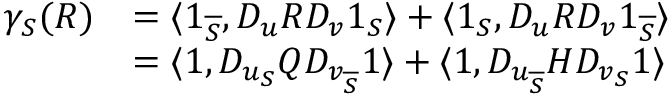Convert formula to latex. <formula><loc_0><loc_0><loc_500><loc_500>\begin{array} { r l } { \gamma _ { S } ( R ) } & { = \langle 1 _ { \overline { S } } , D _ { u } R D _ { v } 1 _ { S } \rangle + \langle 1 _ { S } , D _ { u } R D _ { v } 1 _ { \overline { S } } \rangle } \\ & { = \langle 1 , D _ { u _ { S } } Q D _ { v _ { \overline { S } } } 1 \rangle + \langle 1 , D _ { u _ { \overline { S } } } H D _ { v _ { S } } 1 \rangle } \end{array}</formula> 